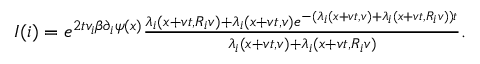<formula> <loc_0><loc_0><loc_500><loc_500>\begin{array} { r } { I ( i ) = e ^ { 2 t v _ { i } \beta \partial _ { i } \psi ( x ) } \frac { \lambda _ { i } ( x + v t , R _ { i } v ) + \lambda _ { i } ( x + v t , v ) e ^ { - ( \lambda _ { i } ( x + v t , v ) + \lambda _ { i } ( x + v t , R _ { i } v ) ) t } } { \lambda _ { i } ( x + v t , v ) + \lambda _ { i } ( x + v t , R _ { i } v ) } . } \end{array}</formula> 